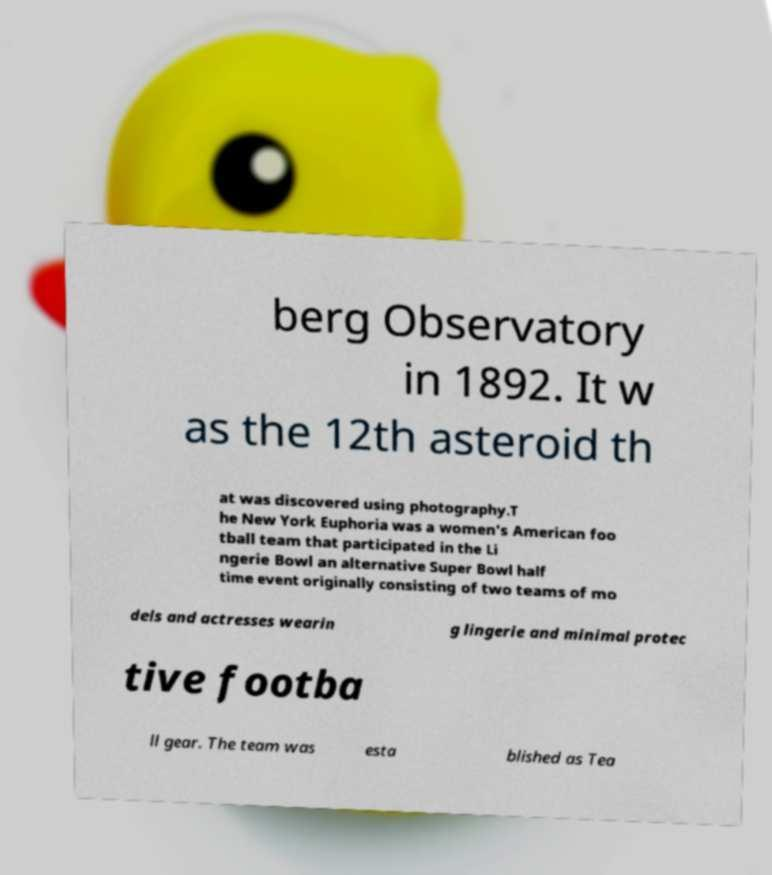Can you read and provide the text displayed in the image?This photo seems to have some interesting text. Can you extract and type it out for me? berg Observatory in 1892. It w as the 12th asteroid th at was discovered using photography.T he New York Euphoria was a women's American foo tball team that participated in the Li ngerie Bowl an alternative Super Bowl half time event originally consisting of two teams of mo dels and actresses wearin g lingerie and minimal protec tive footba ll gear. The team was esta blished as Tea 